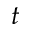Convert formula to latex. <formula><loc_0><loc_0><loc_500><loc_500>t</formula> 